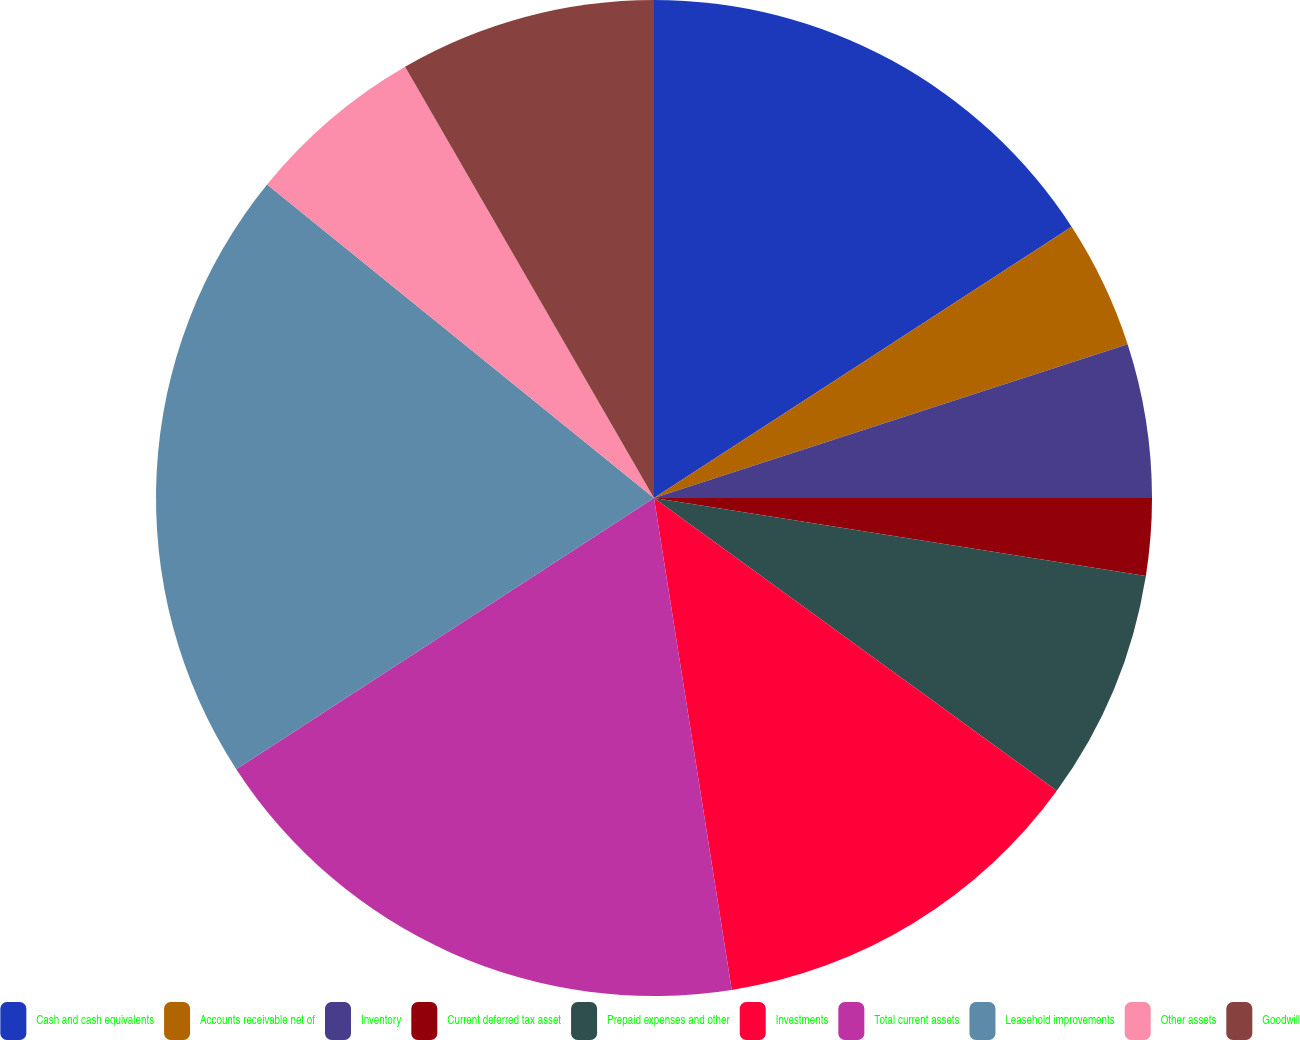Convert chart to OTSL. <chart><loc_0><loc_0><loc_500><loc_500><pie_chart><fcel>Cash and cash equivalents<fcel>Accounts receivable net of<fcel>Inventory<fcel>Current deferred tax asset<fcel>Prepaid expenses and other<fcel>Investments<fcel>Total current assets<fcel>Leasehold improvements<fcel>Other assets<fcel>Goodwill<nl><fcel>15.83%<fcel>4.17%<fcel>5.0%<fcel>2.5%<fcel>7.5%<fcel>12.5%<fcel>18.33%<fcel>20.0%<fcel>5.83%<fcel>8.33%<nl></chart> 